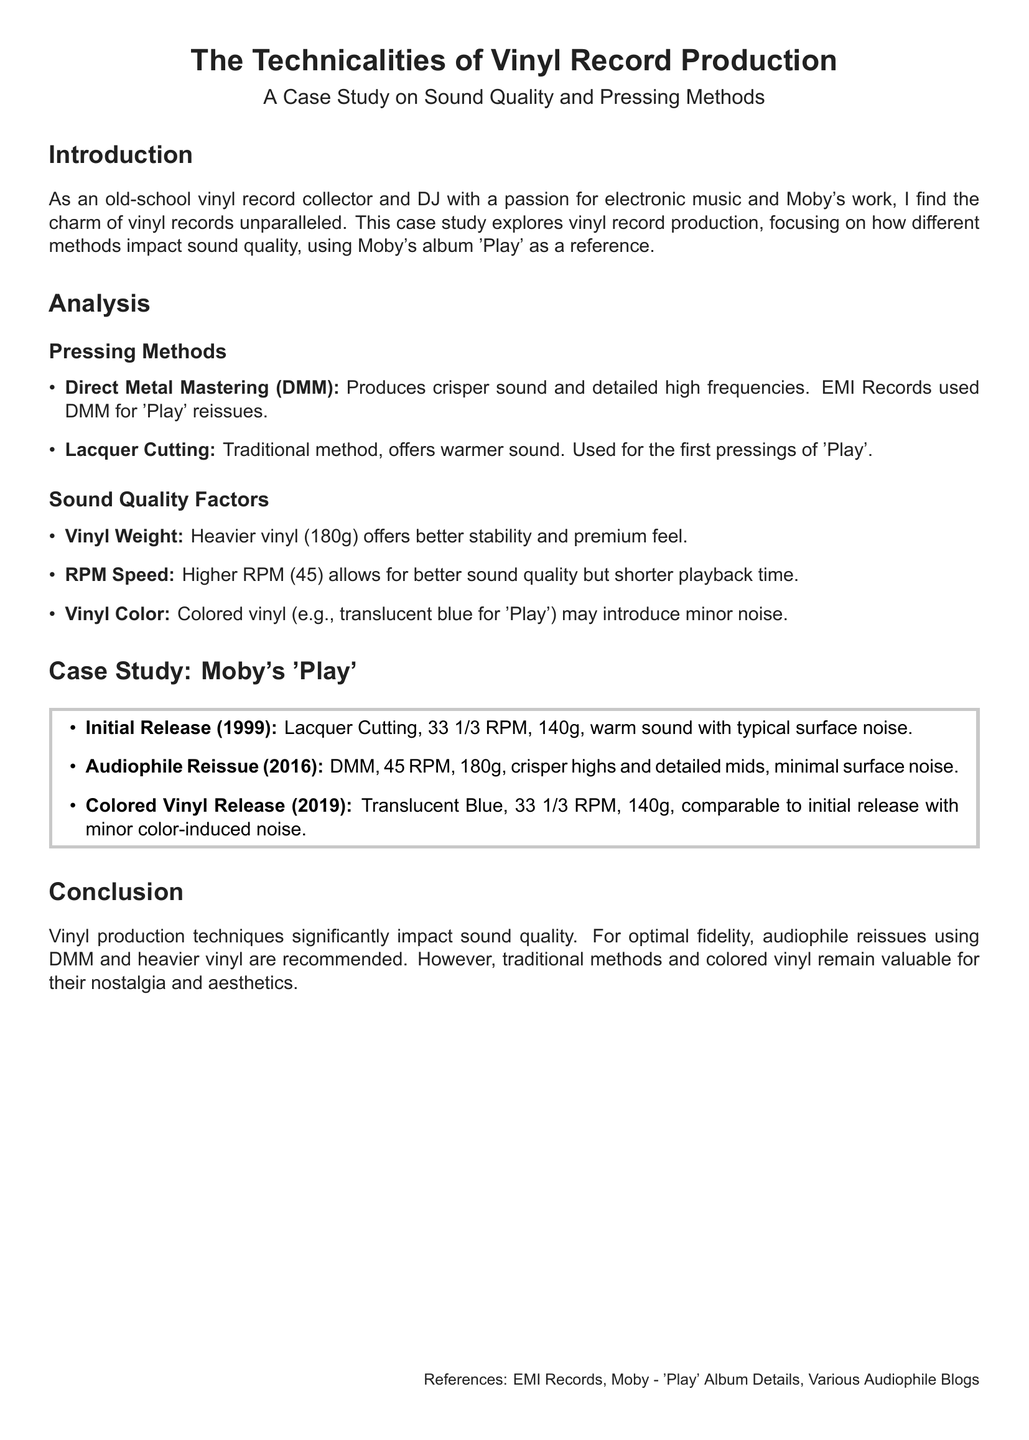What pressing method produces crisper sound? The document states that Direct Metal Mastering (DMM) produces crisper sound and detailed high frequencies.
Answer: Direct Metal Mastering What year was Moby's 'Play' initially released? The initial release of Moby's 'Play' was in 1999, as noted in the case study section.
Answer: 1999 What is the vinyl weight of the audiophile reissue of 'Play'? The audiophile reissue in the document mentions that it is 180g, which is heavier than typical.
Answer: 180g What RPM is used for the colored vinyl release of 'Play'? The document indicates that the colored vinyl release uses 33 1/3 RPM for playback speed.
Answer: 33 1/3 RPM Which method is used for the initial pressings of 'Play'? The case study specifies that Lacquer Cutting was used for the first pressings of 'Play'.
Answer: Lacquer Cutting What color was the vinyl in the 2019 release of 'Play'? The document states that the 2019 release is translucent blue in color.
Answer: Translucent Blue What is the impact of higher RPM on sound quality? According to the document, higher RPM allows for better sound quality but shorter playback time.
Answer: Better sound quality Which produces a warmer sound according to the analysis section? The analysis section mentions that the traditional method of Lacquer Cutting offers a warmer sound.
Answer: Lacquer Cutting What does the document recommend for optimal fidelity? The document concludes that audiophile reissues using DMM and heavier vinyl are recommended for optimal fidelity.
Answer: DMM and heavier vinyl 